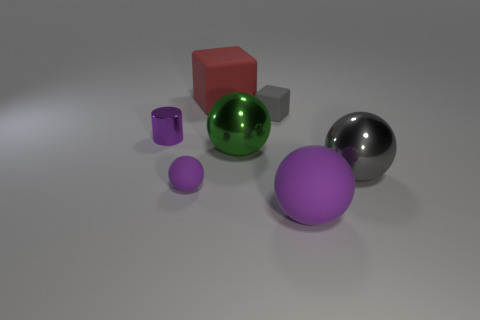Is there any other thing that has the same shape as the purple metal object?
Offer a very short reply. No. Is there a purple rubber thing that has the same size as the red object?
Your response must be concise. Yes. Is the color of the tiny cylinder the same as the tiny rubber ball?
Provide a short and direct response. Yes. There is a ball that is on the left side of the large sphere on the left side of the large purple thing; what is its color?
Keep it short and to the point. Purple. What number of tiny matte things are in front of the tiny metal cylinder and right of the green metal ball?
Provide a short and direct response. 0. What number of small gray things have the same shape as the green shiny thing?
Offer a very short reply. 0. Is the green object made of the same material as the tiny block?
Your response must be concise. No. There is a purple thing right of the small rubber thing that is to the left of the red block; what shape is it?
Offer a terse response. Sphere. There is a small rubber object that is right of the large cube; what number of objects are on the left side of it?
Give a very brief answer. 4. What is the large thing that is behind the big purple ball and in front of the large green metallic sphere made of?
Your response must be concise. Metal. 